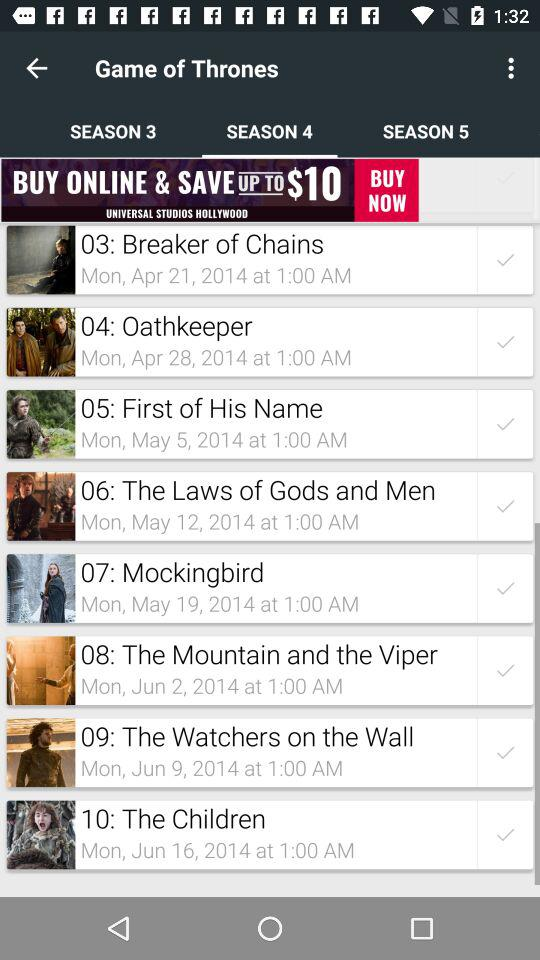What is the date and time of "Mockingbird"? The date and time of "Mockingbird" are Monday, May 19, 2014 and 1:00 AM. 